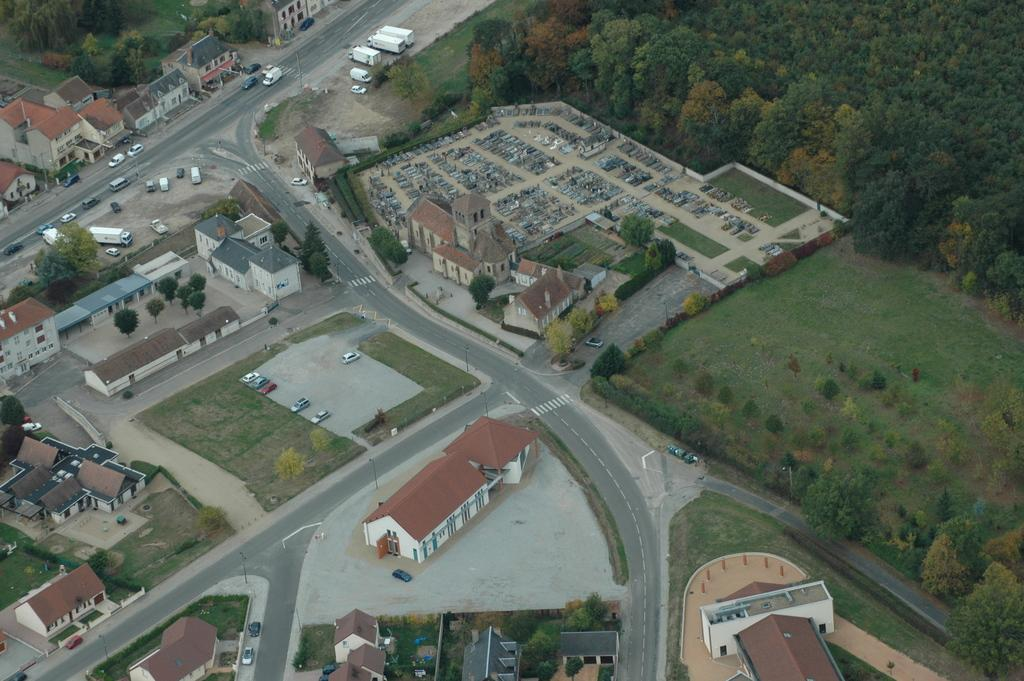What type of structures can be seen in the image? There are houses in the image. What else can be seen in the image besides houses? There are vehicles and trees in the image. How are the vehicles positioned in the image? Some vehicles are parked at the center of the road, and some are parked at the side of the road. What type of oatmeal is being served at the house in the image? There is no oatmeal present in the image, as the focus is on the houses, vehicles, and trees. 